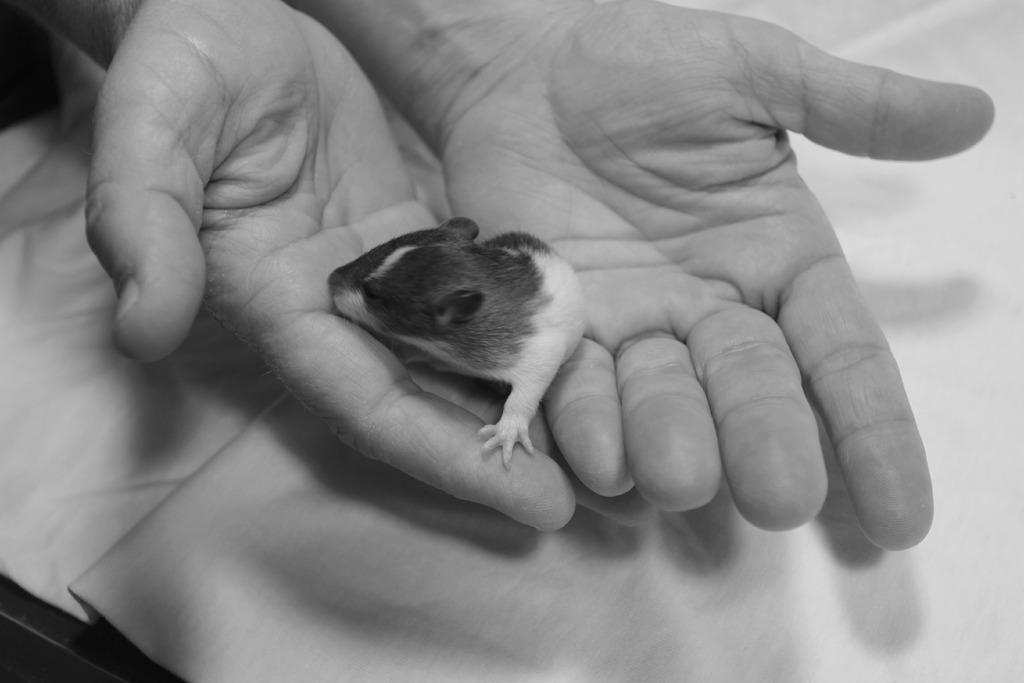What animal is present in the image? There is a rat in the image. How is the rat being held in the image? The rat is in the hand of a person. What type of beast is present in the image? There is no beast present in the image; it features a rat. What wish is being granted by the rat in the image? There is no indication in the image that the rat is granting a wish or involved in any wish-granting activity. 